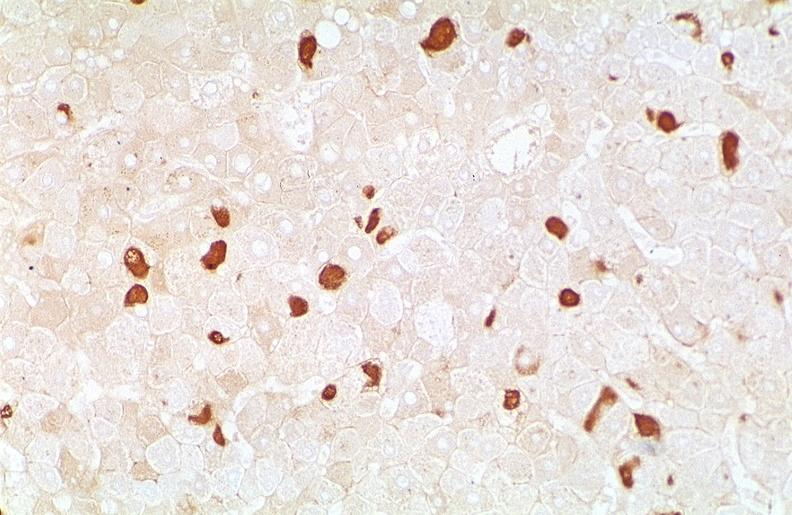does this image show hepatitis b virus, hepatocellular carcinoma?
Answer the question using a single word or phrase. Yes 